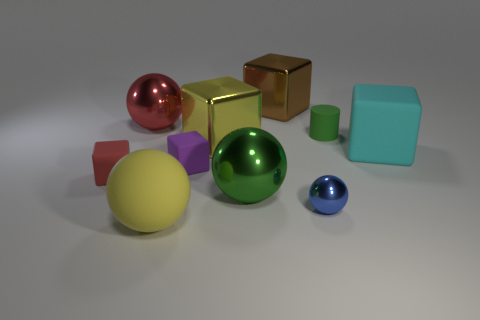There is a big object that is the same color as the small matte cylinder; what is its material?
Offer a very short reply. Metal. How many objects are tiny rubber blocks that are to the right of the large red ball or small rubber cubes right of the red matte thing?
Provide a succinct answer. 1. Does the object on the left side of the large red metallic thing have the same size as the green thing on the right side of the big green metal sphere?
Keep it short and to the point. Yes. There is another tiny object that is the same shape as the tiny red matte thing; what is its color?
Provide a succinct answer. Purple. Is there anything else that has the same shape as the green rubber thing?
Provide a succinct answer. No. Is the number of blue spheres in front of the red metal sphere greater than the number of yellow metal objects in front of the yellow sphere?
Offer a terse response. Yes. There is a matte thing that is on the left side of the metallic sphere to the left of the large object in front of the small sphere; how big is it?
Offer a very short reply. Small. Are the small blue sphere and the yellow object that is in front of the big cyan rubber thing made of the same material?
Your answer should be very brief. No. Is the shape of the big yellow metal object the same as the green rubber object?
Provide a succinct answer. No. How many other objects are the same material as the large brown block?
Keep it short and to the point. 4. 